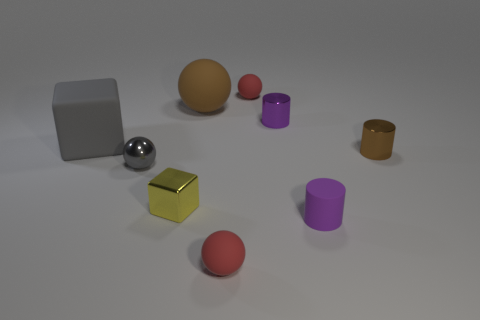Is there a blue matte sphere?
Provide a succinct answer. No. Are there any brown metal cylinders behind the tiny yellow shiny cube?
Your response must be concise. Yes. What is the material of the other tiny purple thing that is the same shape as the purple metal thing?
Ensure brevity in your answer.  Rubber. What number of other objects are the same shape as the big brown thing?
Your answer should be very brief. 3. How many matte things are right of the big thing that is right of the tiny shiny thing that is to the left of the yellow cube?
Give a very brief answer. 3. What number of large brown rubber objects have the same shape as the small brown object?
Give a very brief answer. 0. Is the color of the shiny cylinder that is in front of the tiny purple shiny cylinder the same as the big rubber sphere?
Your response must be concise. Yes. The brown object to the right of the small red thing on the left side of the small red sphere behind the yellow object is what shape?
Provide a short and direct response. Cylinder. Does the purple matte thing have the same size as the shiny thing that is behind the brown shiny cylinder?
Your answer should be compact. Yes. Is there a gray block of the same size as the yellow metal block?
Your response must be concise. No. 